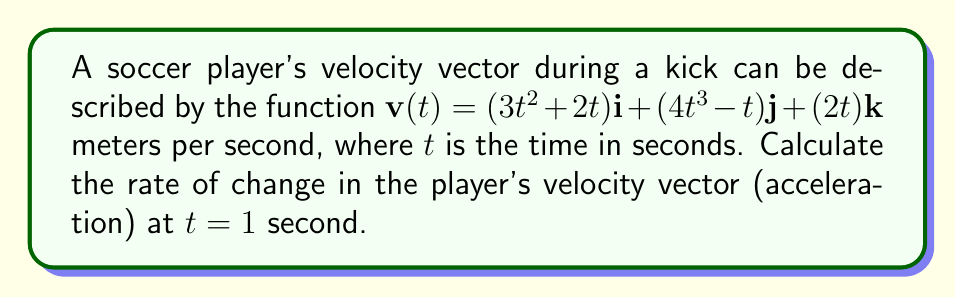Solve this math problem. To find the rate of change in the player's velocity vector (acceleration), we need to differentiate the velocity vector with respect to time.

1) The velocity vector is given as:
   $$\mathbf{v}(t) = (3t^2 + 2t)\mathbf{i} + (4t^3 - t)\mathbf{j} + (2t)\mathbf{k}$$

2) To find the acceleration vector, we differentiate each component:
   $$\mathbf{a}(t) = \frac{d\mathbf{v}(t)}{dt} = \frac{d}{dt}(3t^2 + 2t)\mathbf{i} + \frac{d}{dt}(4t^3 - t)\mathbf{j} + \frac{d}{dt}(2t)\mathbf{k}$$

3) Differentiating each component:
   $$\mathbf{a}(t) = (6t + 2)\mathbf{i} + (12t^2 - 1)\mathbf{j} + 2\mathbf{k}$$

4) Now, we evaluate this at $t = 1$:
   $$\mathbf{a}(1) = (6(1) + 2)\mathbf{i} + (12(1)^2 - 1)\mathbf{j} + 2\mathbf{k}$$
   $$\mathbf{a}(1) = 8\mathbf{i} + 11\mathbf{j} + 2\mathbf{k}$$

5) Therefore, the acceleration vector at $t = 1$ second is $8\mathbf{i} + 11\mathbf{j} + 2\mathbf{k}$ meters per second squared.
Answer: $8\mathbf{i} + 11\mathbf{j} + 2\mathbf{k}$ m/s² 